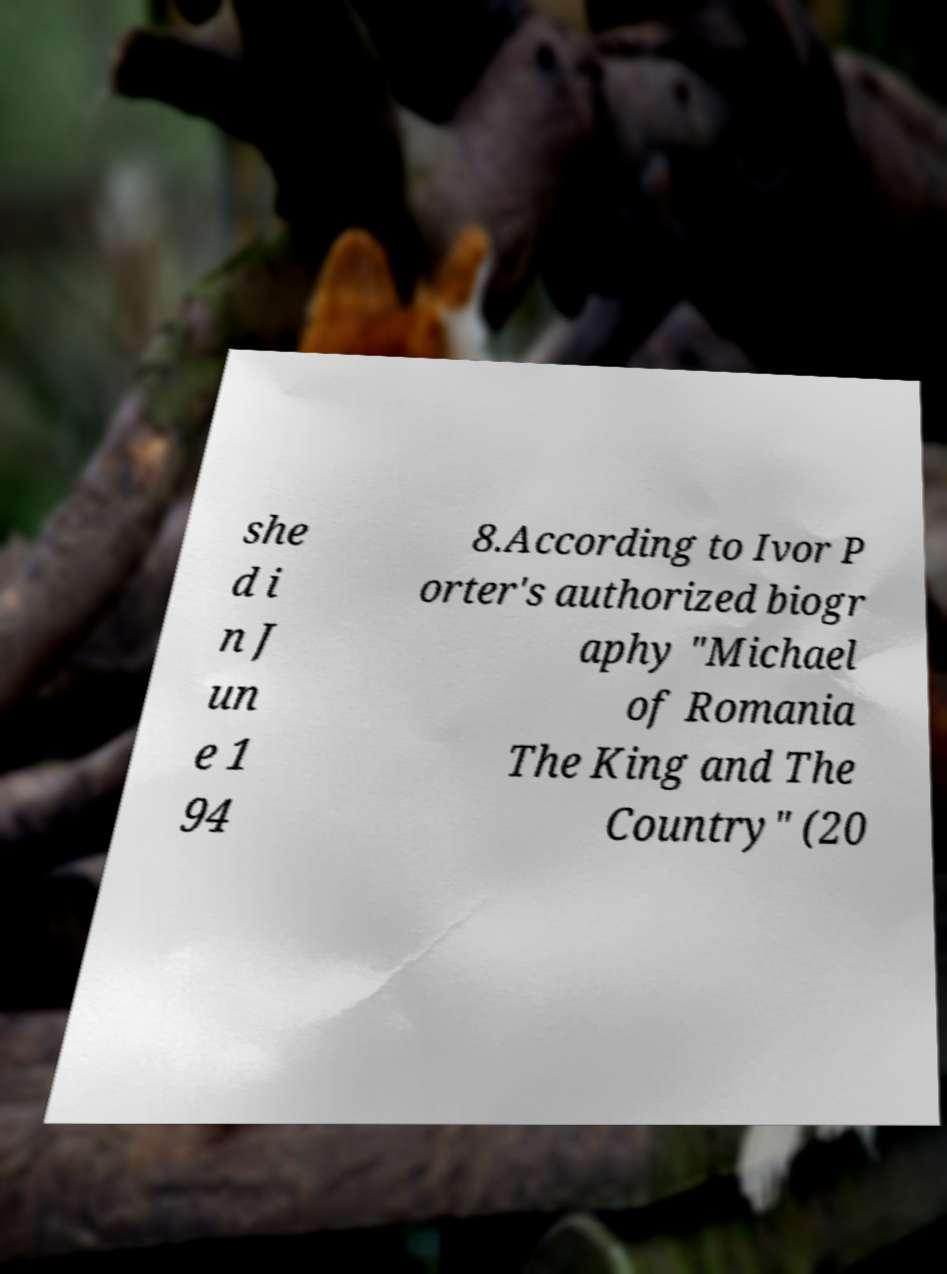For documentation purposes, I need the text within this image transcribed. Could you provide that? she d i n J un e 1 94 8.According to Ivor P orter's authorized biogr aphy "Michael of Romania The King and The Country" (20 